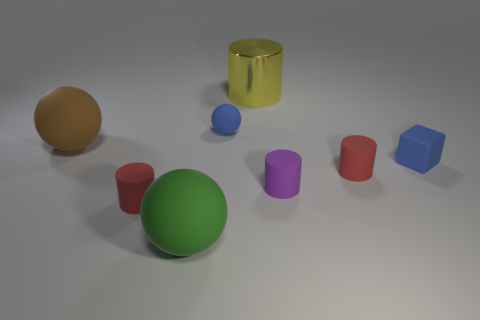Can you describe the arrangement or pattern of the objects? The objects are scattered across the surface with no discernible pattern. They are positioned at various angles and distances from one another, creating a random, almost playful arrangement. This spread of objects with different colors and shapes provides a diverse visual landscape. 